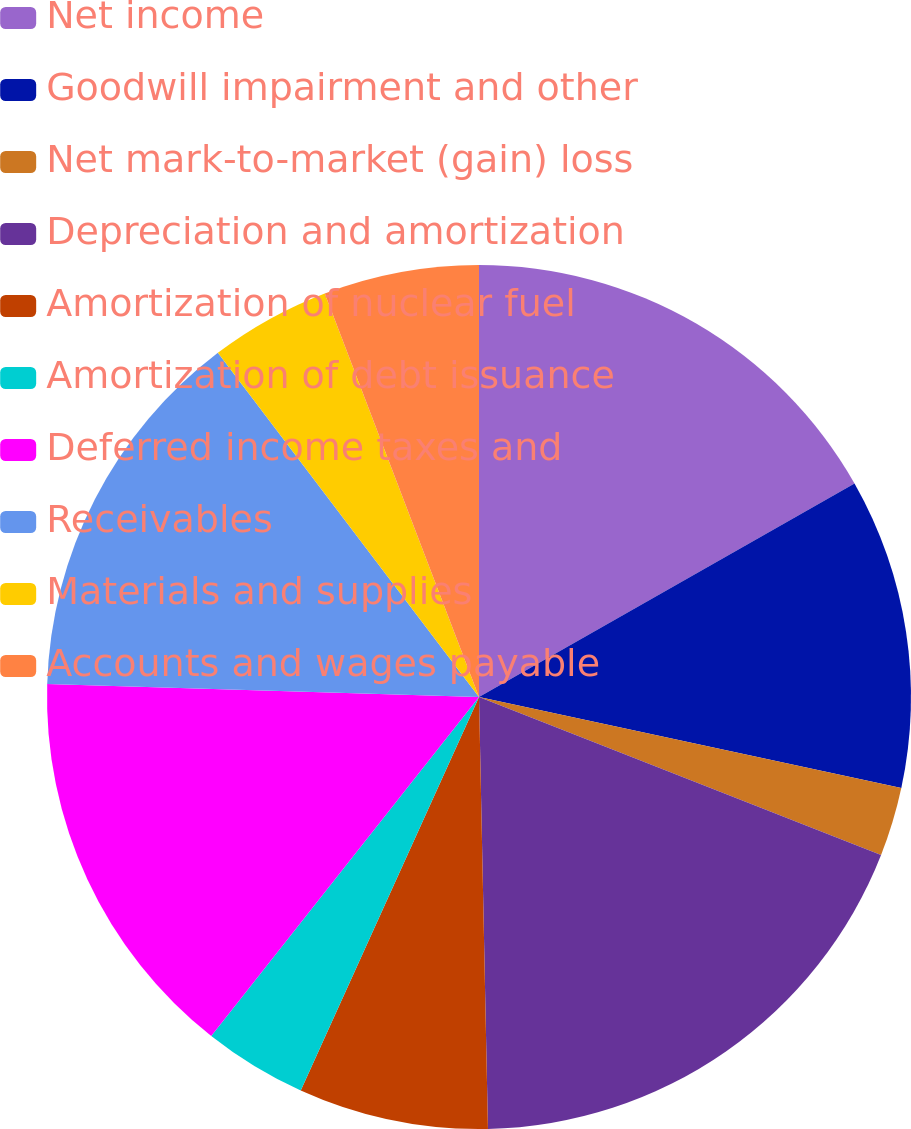<chart> <loc_0><loc_0><loc_500><loc_500><pie_chart><fcel>Net income<fcel>Goodwill impairment and other<fcel>Net mark-to-market (gain) loss<fcel>Depreciation and amortization<fcel>Amortization of nuclear fuel<fcel>Amortization of debt issuance<fcel>Deferred income taxes and<fcel>Receivables<fcel>Materials and supplies<fcel>Accounts and wages payable<nl><fcel>16.77%<fcel>11.61%<fcel>2.58%<fcel>18.71%<fcel>7.1%<fcel>3.87%<fcel>14.84%<fcel>14.19%<fcel>4.52%<fcel>5.81%<nl></chart> 